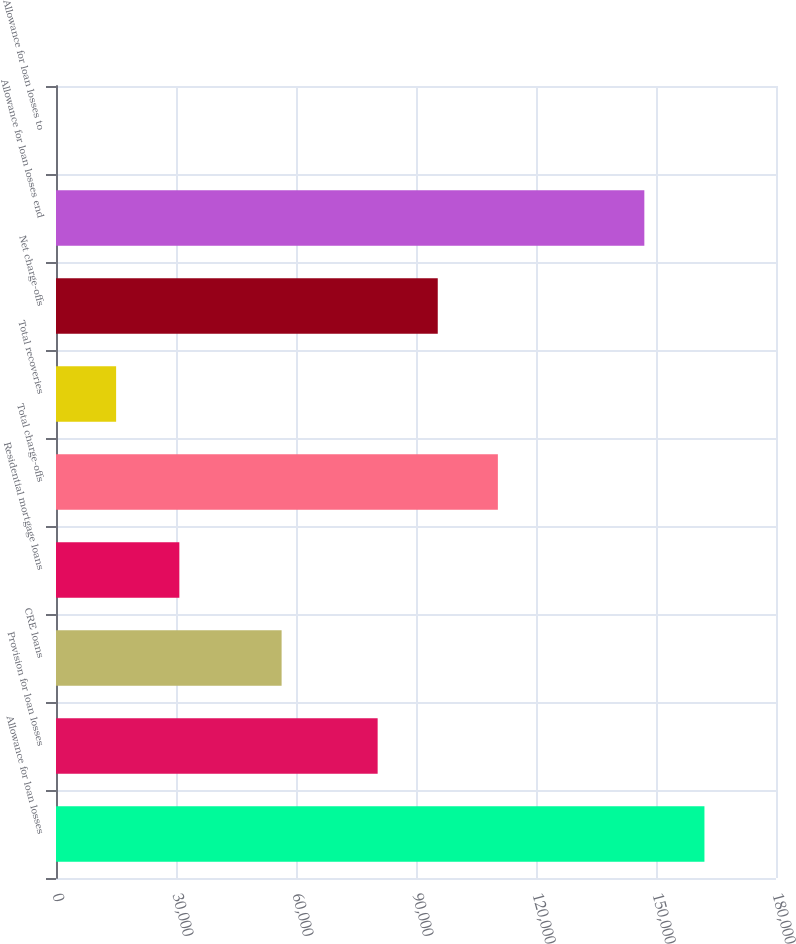Convert chart to OTSL. <chart><loc_0><loc_0><loc_500><loc_500><bar_chart><fcel>Allowance for loan losses<fcel>Provision for loan losses<fcel>CRE loans<fcel>Residential mortgage loans<fcel>Total charge-offs<fcel>Total recoveries<fcel>Net charge-offs<fcel>Allowance for loan losses end<fcel>Allowance for loan losses to<nl><fcel>162111<fcel>80413<fcel>56402<fcel>30837<fcel>110467<fcel>15029.3<fcel>95440<fcel>147084<fcel>2.36<nl></chart> 